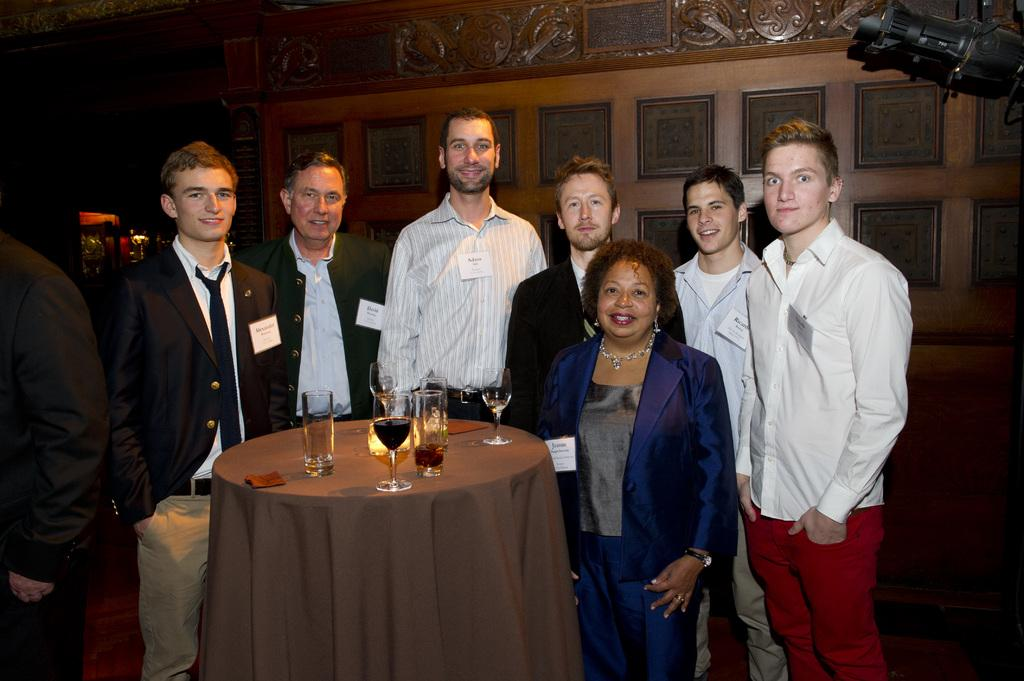How many people are in the image? There are many people in the image. What are the people doing in the image? The people are standing around a table. What objects can be seen on the table? Wine glasses are placed on the table. Can you describe the gender distribution of the people in the image? There are both men and women in the group. What is visible in the background of the image? There is a wall in the background of the image. What type of building can be seen in the image? There is no building visible in the image. 